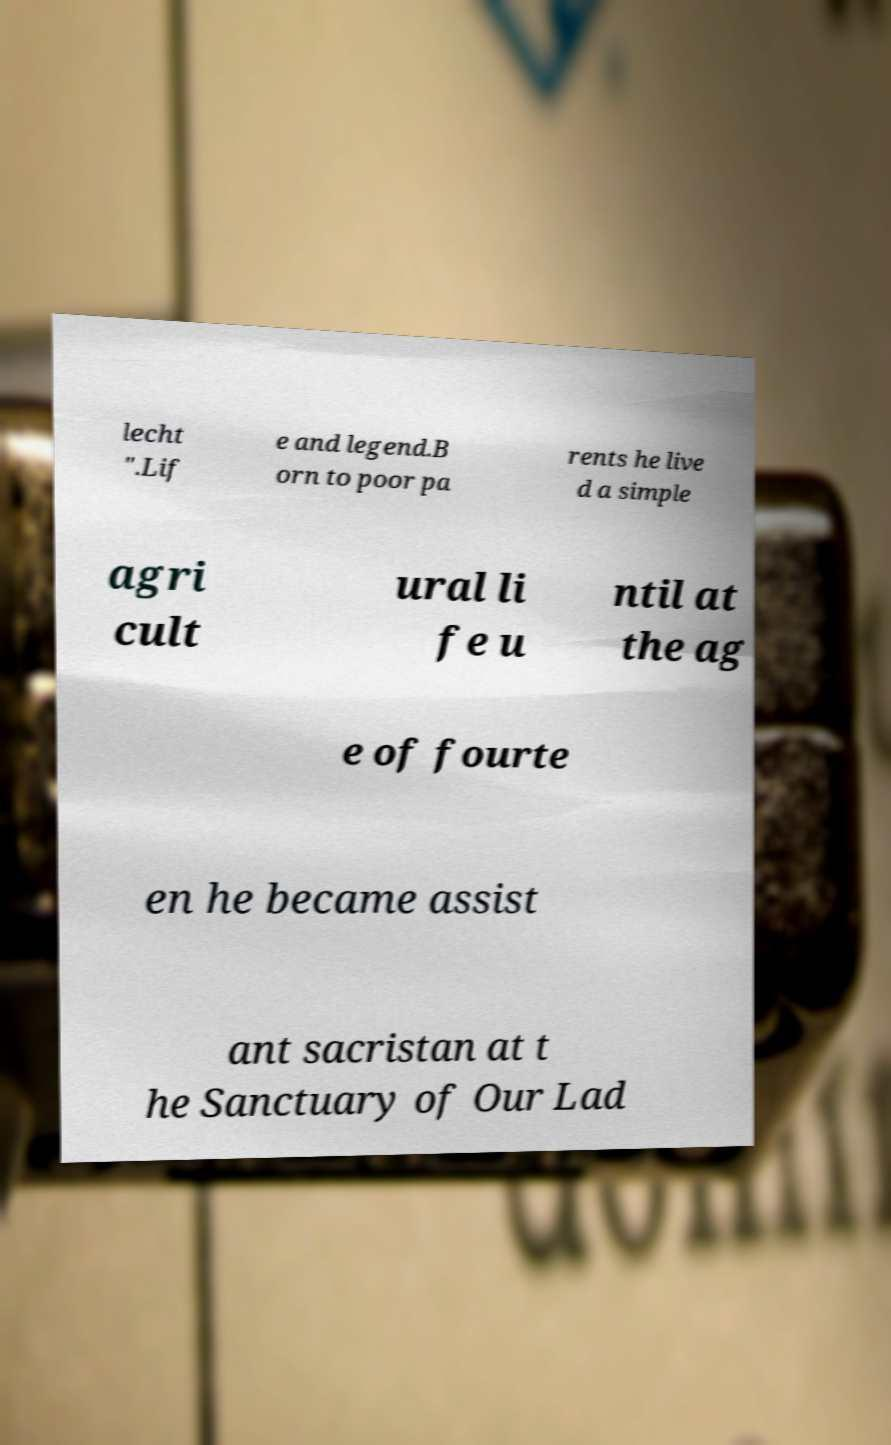Could you extract and type out the text from this image? lecht ".Lif e and legend.B orn to poor pa rents he live d a simple agri cult ural li fe u ntil at the ag e of fourte en he became assist ant sacristan at t he Sanctuary of Our Lad 